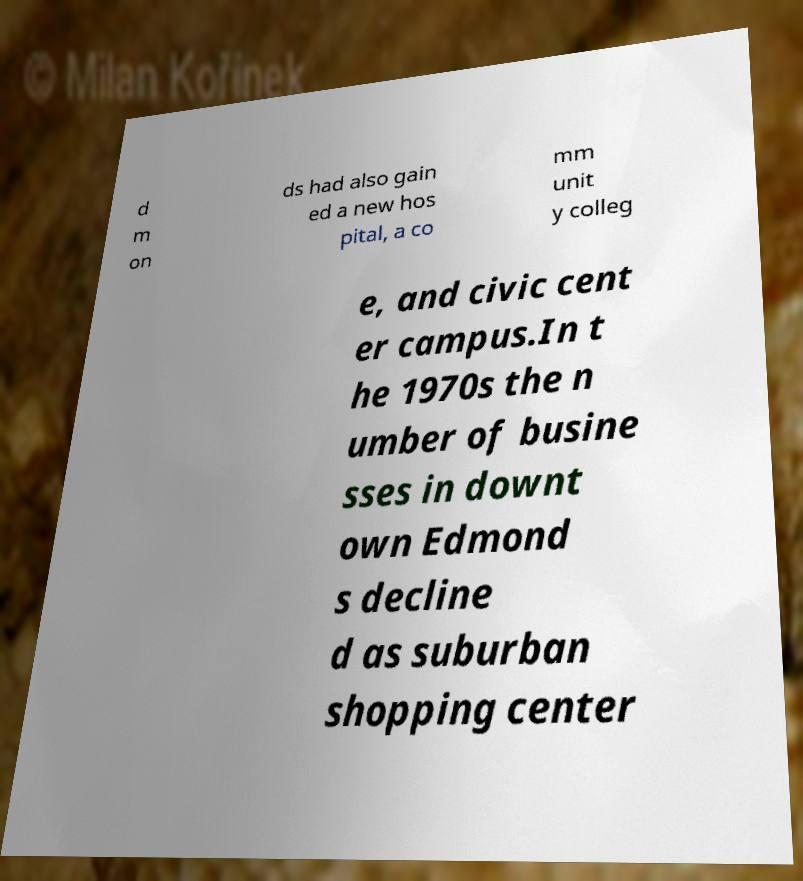For documentation purposes, I need the text within this image transcribed. Could you provide that? d m on ds had also gain ed a new hos pital, a co mm unit y colleg e, and civic cent er campus.In t he 1970s the n umber of busine sses in downt own Edmond s decline d as suburban shopping center 